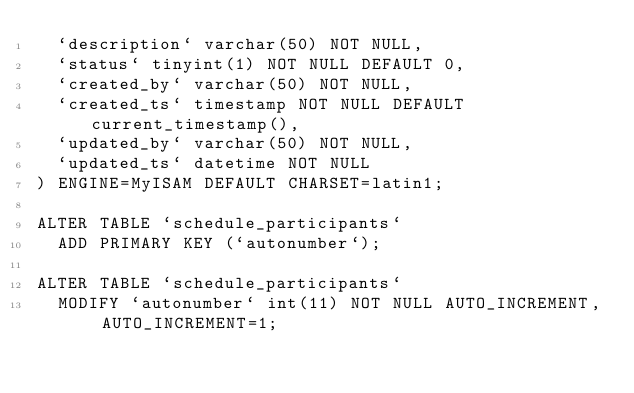Convert code to text. <code><loc_0><loc_0><loc_500><loc_500><_SQL_>  `description` varchar(50) NOT NULL,
  `status` tinyint(1) NOT NULL DEFAULT 0,
  `created_by` varchar(50) NOT NULL,
  `created_ts` timestamp NOT NULL DEFAULT current_timestamp(),
  `updated_by` varchar(50) NOT NULL,
  `updated_ts` datetime NOT NULL
) ENGINE=MyISAM DEFAULT CHARSET=latin1;

ALTER TABLE `schedule_participants`
  ADD PRIMARY KEY (`autonumber`);

ALTER TABLE `schedule_participants`
  MODIFY `autonumber` int(11) NOT NULL AUTO_INCREMENT, AUTO_INCREMENT=1;
</code> 